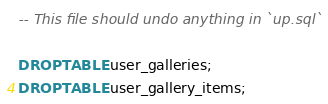<code> <loc_0><loc_0><loc_500><loc_500><_SQL_>-- This file should undo anything in `up.sql`

DROP TABLE user_galleries;
DROP TABLE user_gallery_items;
</code> 